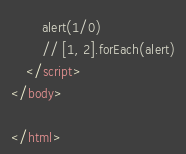Convert code to text. <code><loc_0><loc_0><loc_500><loc_500><_HTML_>        alert(1/0)
        // [1, 2].forEach(alert)
    </script>
</body>

</html></code> 